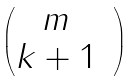<formula> <loc_0><loc_0><loc_500><loc_500>\begin{pmatrix} m & \\ k + 1 & \end{pmatrix}</formula> 